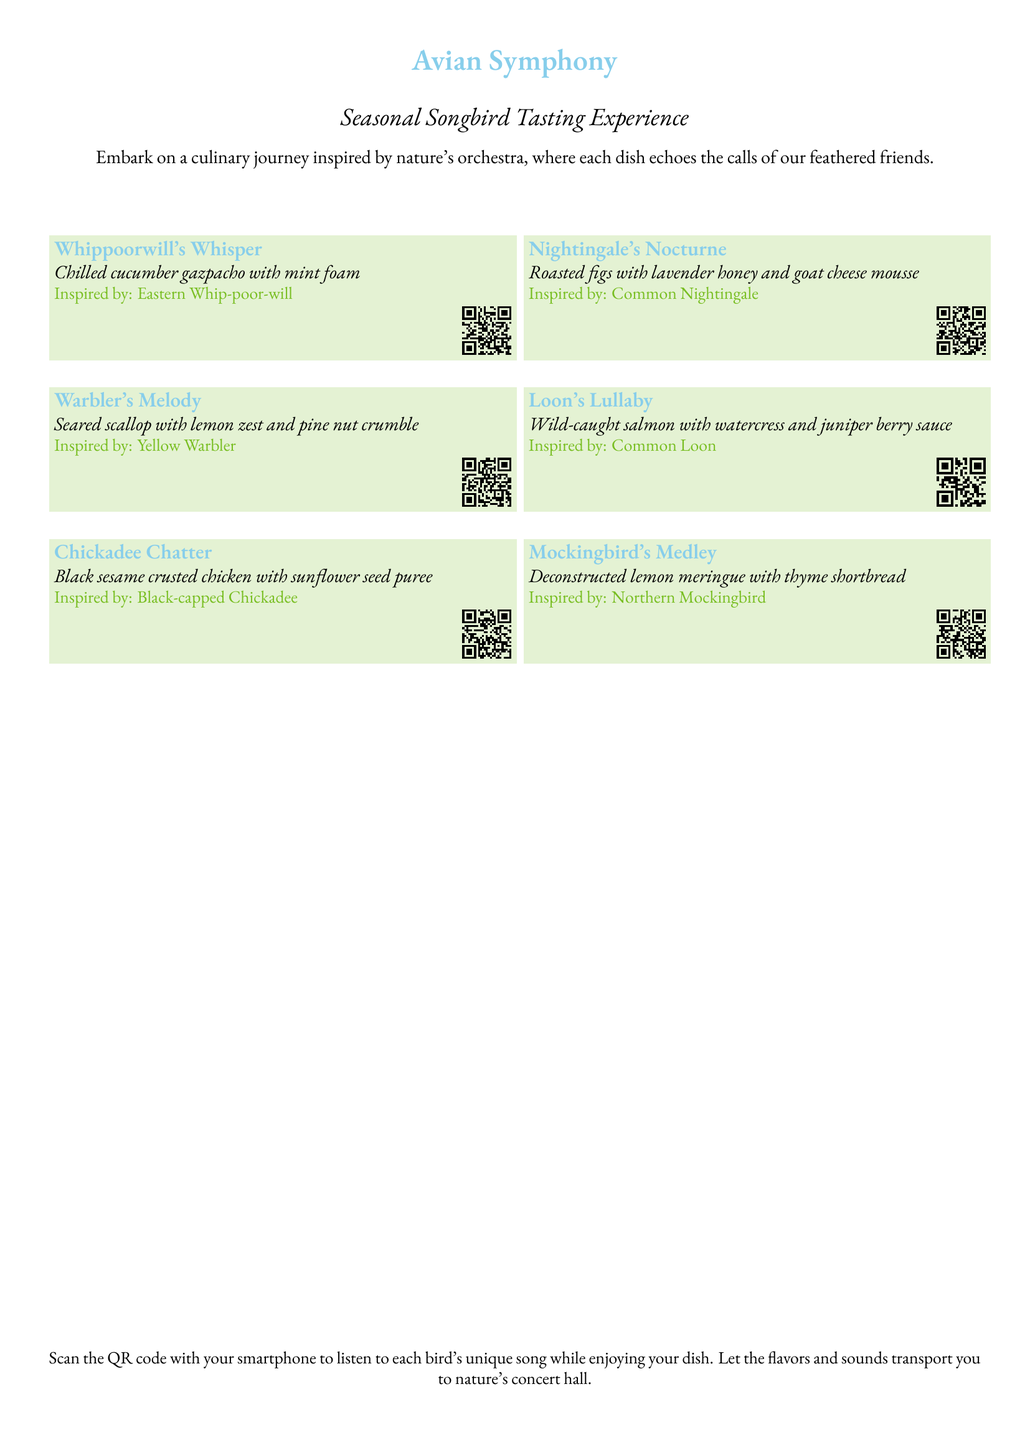What is the title of the menu? The title of the menu is prominently displayed at the top of the document.
Answer: Avian Symphony How many dishes are featured in the menu? There are six dishes listed in the document.
Answer: 6 What is the first dish called? The first dish is identified in the first section of the menu.
Answer: Whippoorwill's Whisper Which bird inspires the dish named "Loon's Lullaby"? The bird associated with "Loon's Lullaby" is mentioned in the description of that dish.
Answer: Common Loon What is the main ingredient of "Mockingbird's Medley"? The main ingredient of this dish can be found in the dish description.
Answer: Deconstructed lemon meringue How can you listen to each bird's song? The method to listen to the bird's song is explained at the bottom of the document.
Answer: Scan the QR code What type of dining experience does this menu offer? The type of experience is described in the introductory paragraphs of the document.
Answer: Tasting experience What color is associated with the dish descriptions? The color used in the dish descriptions can be identified from the document formatting.
Answer: Leaf green 